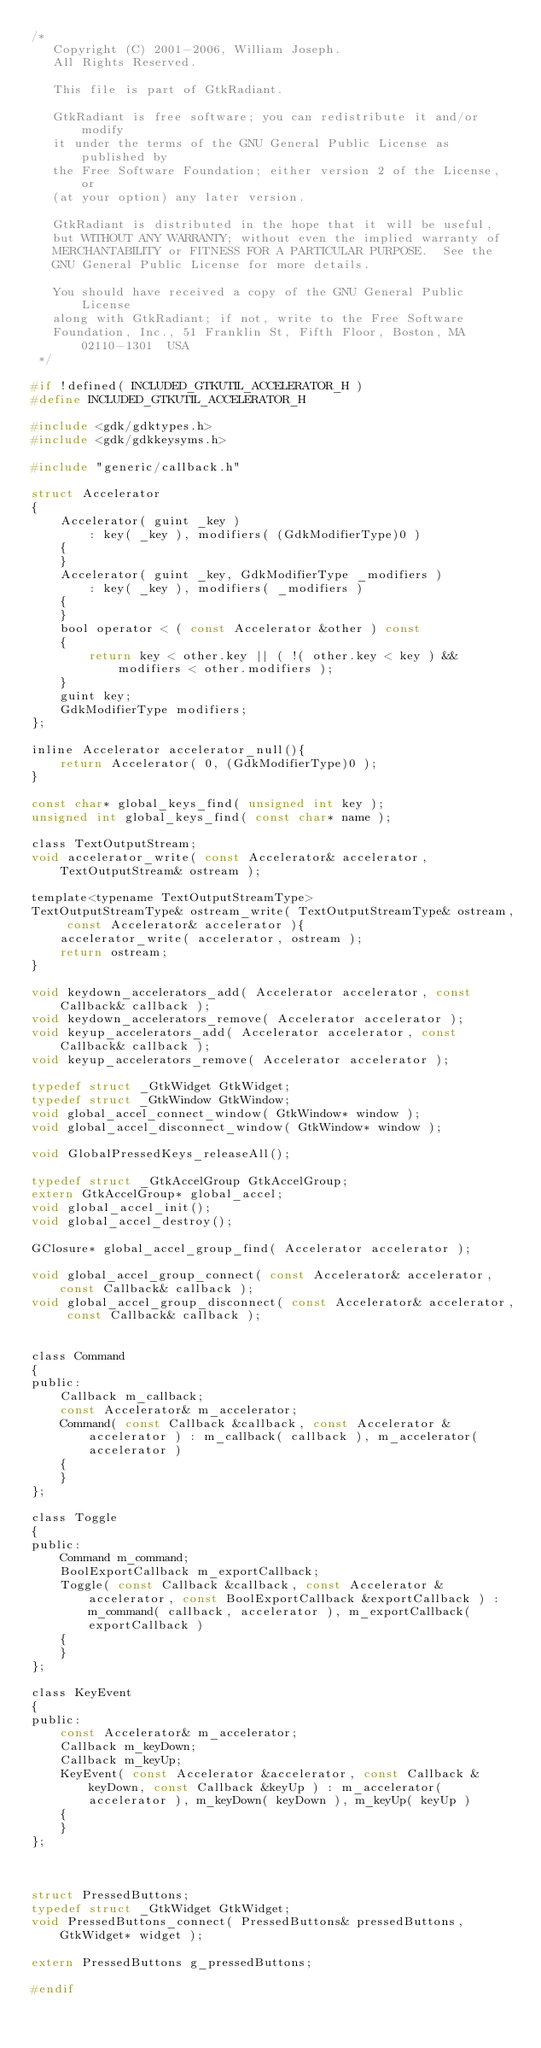<code> <loc_0><loc_0><loc_500><loc_500><_C_>/*
   Copyright (C) 2001-2006, William Joseph.
   All Rights Reserved.

   This file is part of GtkRadiant.

   GtkRadiant is free software; you can redistribute it and/or modify
   it under the terms of the GNU General Public License as published by
   the Free Software Foundation; either version 2 of the License, or
   (at your option) any later version.

   GtkRadiant is distributed in the hope that it will be useful,
   but WITHOUT ANY WARRANTY; without even the implied warranty of
   MERCHANTABILITY or FITNESS FOR A PARTICULAR PURPOSE.  See the
   GNU General Public License for more details.

   You should have received a copy of the GNU General Public License
   along with GtkRadiant; if not, write to the Free Software
   Foundation, Inc., 51 Franklin St, Fifth Floor, Boston, MA  02110-1301  USA
 */

#if !defined( INCLUDED_GTKUTIL_ACCELERATOR_H )
#define INCLUDED_GTKUTIL_ACCELERATOR_H

#include <gdk/gdktypes.h>
#include <gdk/gdkkeysyms.h>

#include "generic/callback.h"

struct Accelerator
{
	Accelerator( guint _key )
		: key( _key ), modifiers( (GdkModifierType)0 )
	{
	}
	Accelerator( guint _key, GdkModifierType _modifiers )
		: key( _key ), modifiers( _modifiers )
	{
	}
	bool operator < ( const Accelerator &other ) const
	{
		return key < other.key || ( !( other.key < key ) && modifiers < other.modifiers );
	}
	guint key;
	GdkModifierType modifiers;
};

inline Accelerator accelerator_null(){
	return Accelerator( 0, (GdkModifierType)0 );
}

const char* global_keys_find( unsigned int key );
unsigned int global_keys_find( const char* name );

class TextOutputStream;
void accelerator_write( const Accelerator& accelerator, TextOutputStream& ostream );

template<typename TextOutputStreamType>
TextOutputStreamType& ostream_write( TextOutputStreamType& ostream, const Accelerator& accelerator ){
	accelerator_write( accelerator, ostream );
	return ostream;
}

void keydown_accelerators_add( Accelerator accelerator, const Callback& callback );
void keydown_accelerators_remove( Accelerator accelerator );
void keyup_accelerators_add( Accelerator accelerator, const Callback& callback );
void keyup_accelerators_remove( Accelerator accelerator );

typedef struct _GtkWidget GtkWidget;
typedef struct _GtkWindow GtkWindow;
void global_accel_connect_window( GtkWindow* window );
void global_accel_disconnect_window( GtkWindow* window );

void GlobalPressedKeys_releaseAll();

typedef struct _GtkAccelGroup GtkAccelGroup;
extern GtkAccelGroup* global_accel;
void global_accel_init();
void global_accel_destroy();

GClosure* global_accel_group_find( Accelerator accelerator );

void global_accel_group_connect( const Accelerator& accelerator, const Callback& callback );
void global_accel_group_disconnect( const Accelerator& accelerator, const Callback& callback );


class Command
{
public:
	Callback m_callback;
	const Accelerator& m_accelerator;
	Command( const Callback &callback, const Accelerator &accelerator ) : m_callback( callback ), m_accelerator( accelerator )
	{
	}
};

class Toggle
{
public:
	Command m_command;
	BoolExportCallback m_exportCallback;
	Toggle( const Callback &callback, const Accelerator &accelerator, const BoolExportCallback &exportCallback ) : m_command( callback, accelerator ), m_exportCallback( exportCallback )
	{
	}
};

class KeyEvent
{
public:
	const Accelerator& m_accelerator;
	Callback m_keyDown;
	Callback m_keyUp;
	KeyEvent( const Accelerator &accelerator, const Callback &keyDown, const Callback &keyUp ) : m_accelerator( accelerator ), m_keyDown( keyDown ), m_keyUp( keyUp )
	{
	}
};



struct PressedButtons;
typedef struct _GtkWidget GtkWidget;
void PressedButtons_connect( PressedButtons& pressedButtons, GtkWidget* widget );

extern PressedButtons g_pressedButtons;

#endif
</code> 